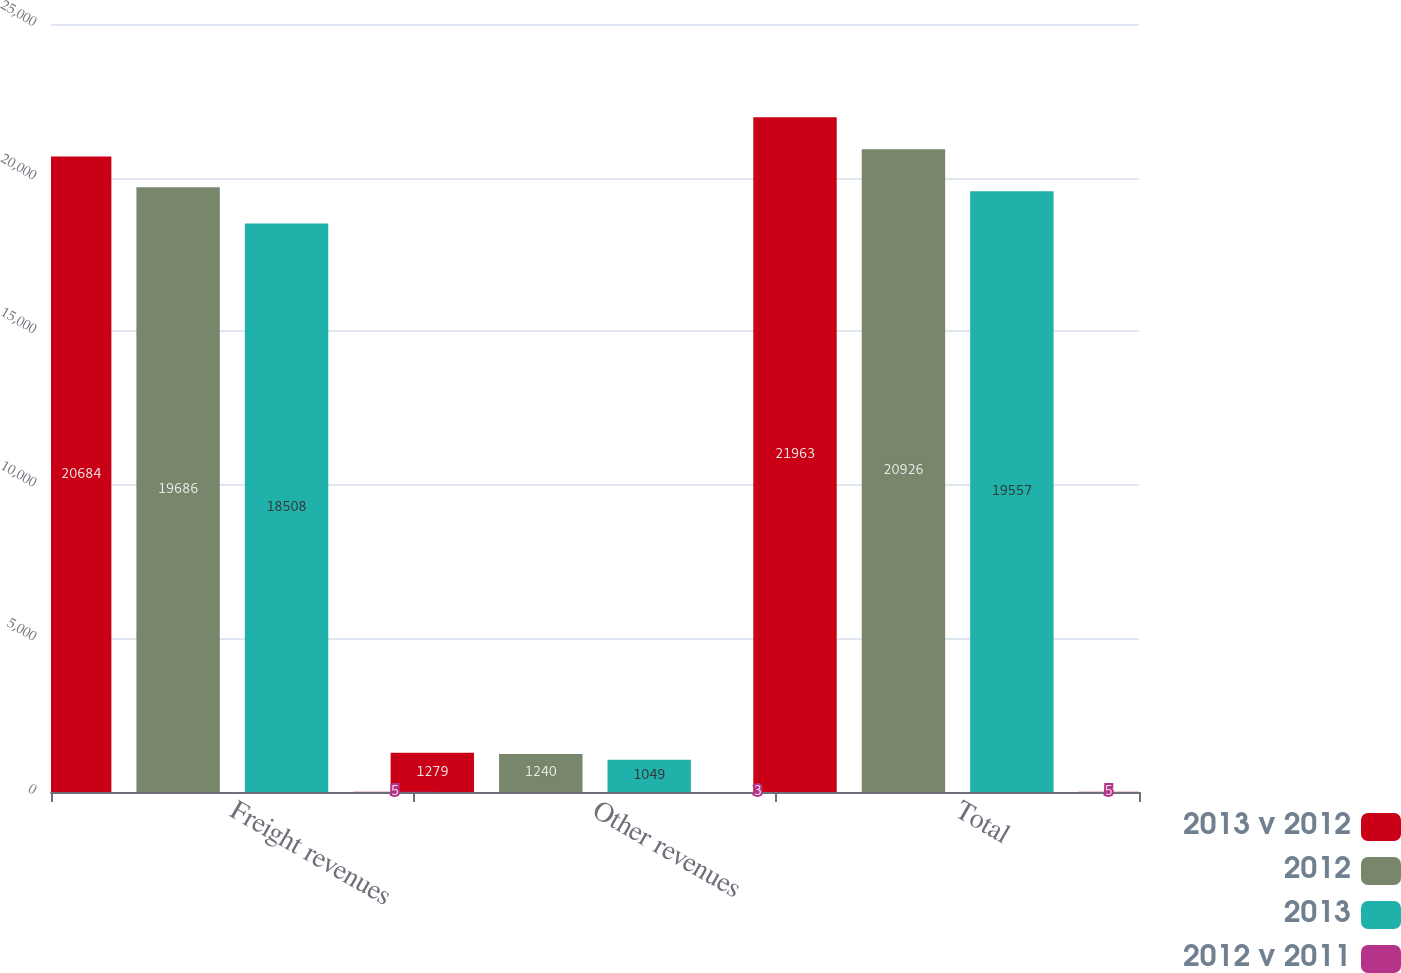Convert chart. <chart><loc_0><loc_0><loc_500><loc_500><stacked_bar_chart><ecel><fcel>Freight revenues<fcel>Other revenues<fcel>Total<nl><fcel>2013 v 2012<fcel>20684<fcel>1279<fcel>21963<nl><fcel>2012<fcel>19686<fcel>1240<fcel>20926<nl><fcel>2013<fcel>18508<fcel>1049<fcel>19557<nl><fcel>2012 v 2011<fcel>5<fcel>3<fcel>5<nl></chart> 